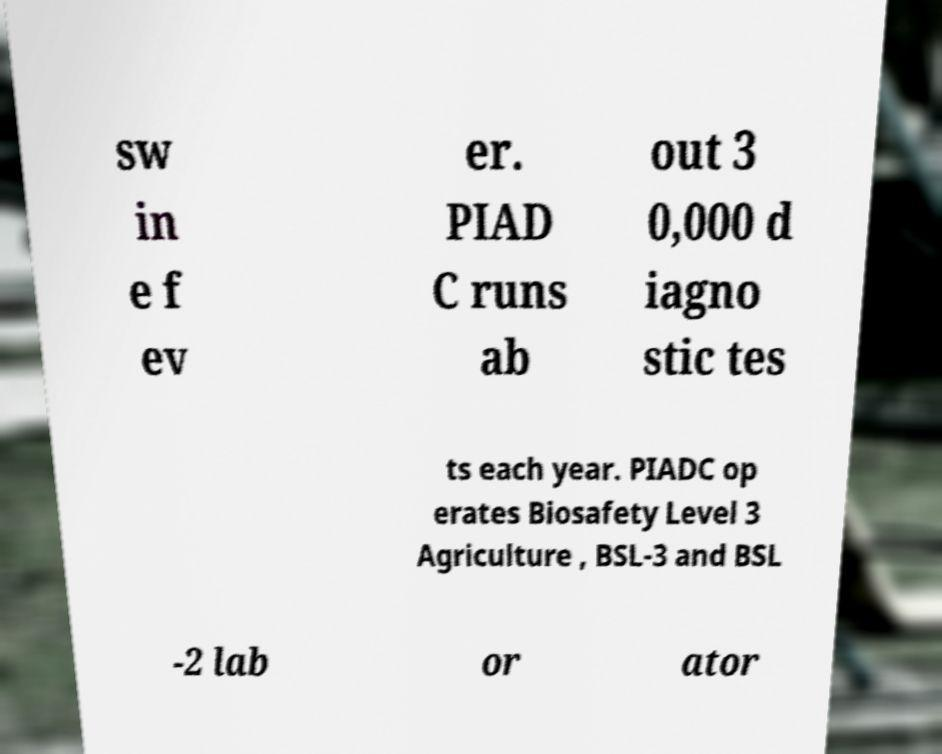Please read and relay the text visible in this image. What does it say? sw in e f ev er. PIAD C runs ab out 3 0,000 d iagno stic tes ts each year. PIADC op erates Biosafety Level 3 Agriculture , BSL-3 and BSL -2 lab or ator 